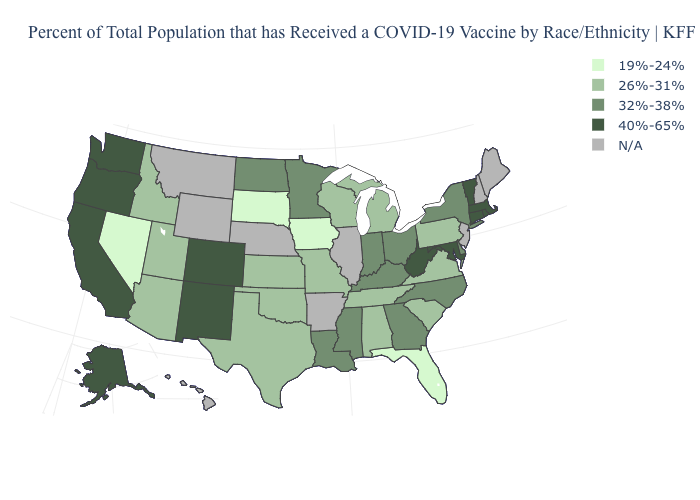What is the value of New Hampshire?
Short answer required. N/A. What is the value of Pennsylvania?
Be succinct. 26%-31%. Name the states that have a value in the range 26%-31%?
Quick response, please. Alabama, Arizona, Idaho, Kansas, Michigan, Missouri, Oklahoma, Pennsylvania, South Carolina, Tennessee, Texas, Utah, Virginia, Wisconsin. What is the value of Alaska?
Answer briefly. 40%-65%. Which states hav the highest value in the West?
Write a very short answer. Alaska, California, Colorado, New Mexico, Oregon, Washington. Name the states that have a value in the range N/A?
Short answer required. Arkansas, Hawaii, Illinois, Maine, Montana, Nebraska, New Hampshire, New Jersey, Wyoming. Which states have the lowest value in the MidWest?
Keep it brief. Iowa, South Dakota. Does the first symbol in the legend represent the smallest category?
Keep it brief. Yes. Does Pennsylvania have the lowest value in the Northeast?
Keep it brief. Yes. Name the states that have a value in the range N/A?
Give a very brief answer. Arkansas, Hawaii, Illinois, Maine, Montana, Nebraska, New Hampshire, New Jersey, Wyoming. Does Oregon have the highest value in the USA?
Write a very short answer. Yes. What is the value of Minnesota?
Answer briefly. 32%-38%. Name the states that have a value in the range 32%-38%?
Write a very short answer. Delaware, Georgia, Indiana, Kentucky, Louisiana, Minnesota, Mississippi, New York, North Carolina, North Dakota, Ohio. Name the states that have a value in the range 40%-65%?
Quick response, please. Alaska, California, Colorado, Connecticut, Maryland, Massachusetts, New Mexico, Oregon, Rhode Island, Vermont, Washington, West Virginia. 